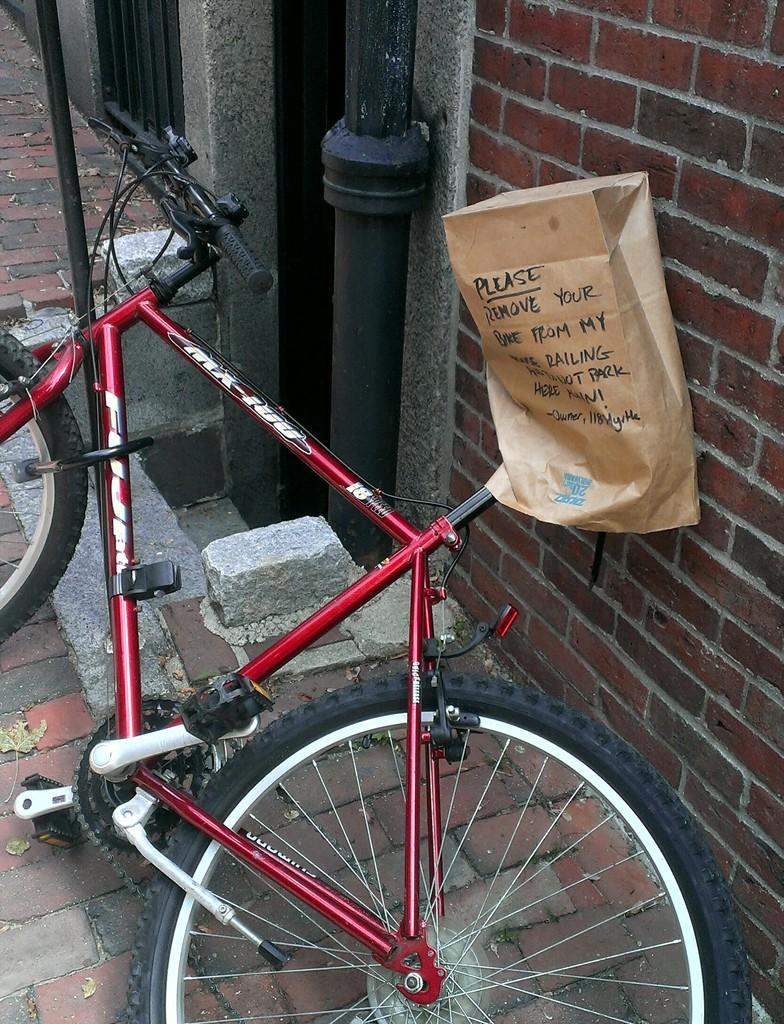How would you summarize this image in a sentence or two? On the right side of the picture we can see the wall, pipe. In this picture we can see a bicycle is parked and a brown cover on the handle of a bicycle. There is something written on the cover. 